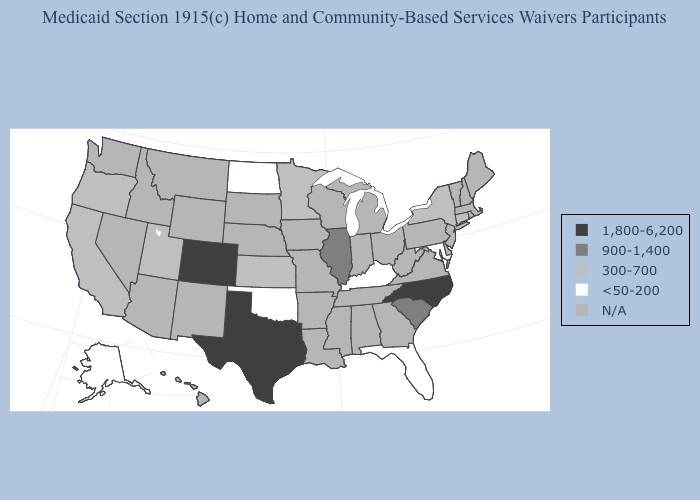Among the states that border South Dakota , which have the lowest value?
Short answer required. North Dakota. Which states have the lowest value in the USA?
Short answer required. Alaska, Florida, Kentucky, Maryland, North Dakota, Oklahoma. What is the value of Hawaii?
Keep it brief. N/A. Which states hav the highest value in the Northeast?
Write a very short answer. Connecticut, New York. Among the states that border South Dakota , does North Dakota have the lowest value?
Be succinct. Yes. What is the highest value in states that border North Carolina?
Give a very brief answer. 900-1,400. What is the highest value in the MidWest ?
Keep it brief. 900-1,400. Among the states that border Missouri , does Kentucky have the highest value?
Give a very brief answer. No. What is the value of Oregon?
Keep it brief. 300-700. Name the states that have a value in the range <50-200?
Concise answer only. Alaska, Florida, Kentucky, Maryland, North Dakota, Oklahoma. What is the value of Nevada?
Quick response, please. N/A. 